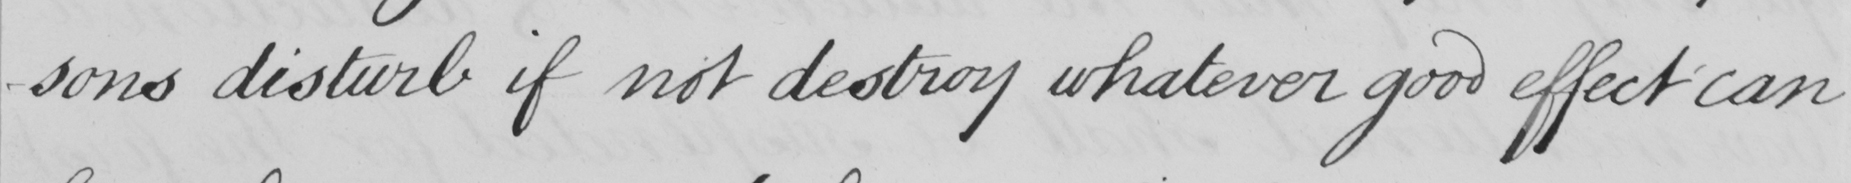Please provide the text content of this handwritten line. -sons disturb if not destroy whatever good effect can 